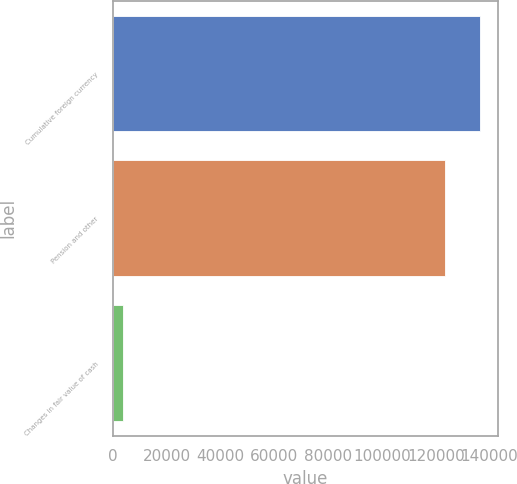Convert chart. <chart><loc_0><loc_0><loc_500><loc_500><bar_chart><fcel>Cumulative foreign currency<fcel>Pension and other<fcel>Changes in fair value of cash<nl><fcel>136428<fcel>123301<fcel>4006<nl></chart> 